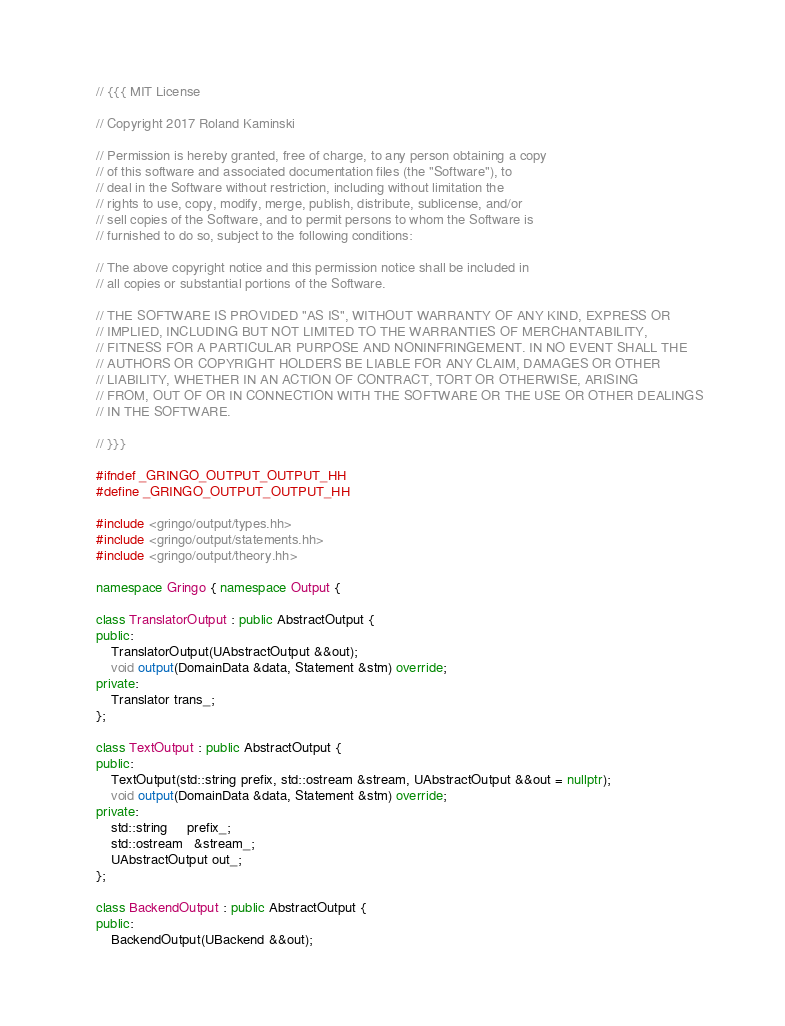<code> <loc_0><loc_0><loc_500><loc_500><_C++_>// {{{ MIT License

// Copyright 2017 Roland Kaminski

// Permission is hereby granted, free of charge, to any person obtaining a copy
// of this software and associated documentation files (the "Software"), to
// deal in the Software without restriction, including without limitation the
// rights to use, copy, modify, merge, publish, distribute, sublicense, and/or
// sell copies of the Software, and to permit persons to whom the Software is
// furnished to do so, subject to the following conditions:

// The above copyright notice and this permission notice shall be included in
// all copies or substantial portions of the Software.

// THE SOFTWARE IS PROVIDED "AS IS", WITHOUT WARRANTY OF ANY KIND, EXPRESS OR
// IMPLIED, INCLUDING BUT NOT LIMITED TO THE WARRANTIES OF MERCHANTABILITY,
// FITNESS FOR A PARTICULAR PURPOSE AND NONINFRINGEMENT. IN NO EVENT SHALL THE
// AUTHORS OR COPYRIGHT HOLDERS BE LIABLE FOR ANY CLAIM, DAMAGES OR OTHER
// LIABILITY, WHETHER IN AN ACTION OF CONTRACT, TORT OR OTHERWISE, ARISING
// FROM, OUT OF OR IN CONNECTION WITH THE SOFTWARE OR THE USE OR OTHER DEALINGS
// IN THE SOFTWARE.

// }}}

#ifndef _GRINGO_OUTPUT_OUTPUT_HH
#define _GRINGO_OUTPUT_OUTPUT_HH

#include <gringo/output/types.hh>
#include <gringo/output/statements.hh>
#include <gringo/output/theory.hh>

namespace Gringo { namespace Output {

class TranslatorOutput : public AbstractOutput {
public:
    TranslatorOutput(UAbstractOutput &&out);
    void output(DomainData &data, Statement &stm) override;
private:
    Translator trans_;
};

class TextOutput : public AbstractOutput {
public:
    TextOutput(std::string prefix, std::ostream &stream, UAbstractOutput &&out = nullptr);
    void output(DomainData &data, Statement &stm) override;
private:
    std::string     prefix_;
    std::ostream   &stream_;
    UAbstractOutput out_;
};

class BackendOutput : public AbstractOutput {
public:
    BackendOutput(UBackend &&out);</code> 